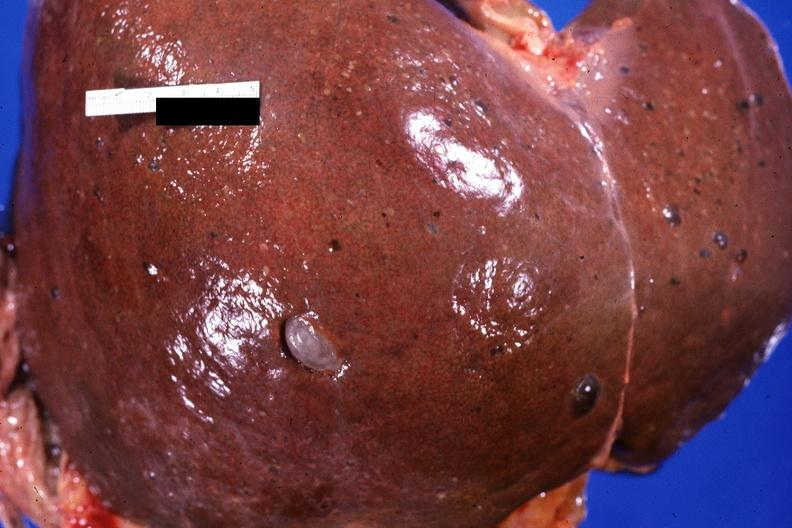does this image show liver, adult polycystic kidney?
Answer the question using a single word or phrase. Yes 